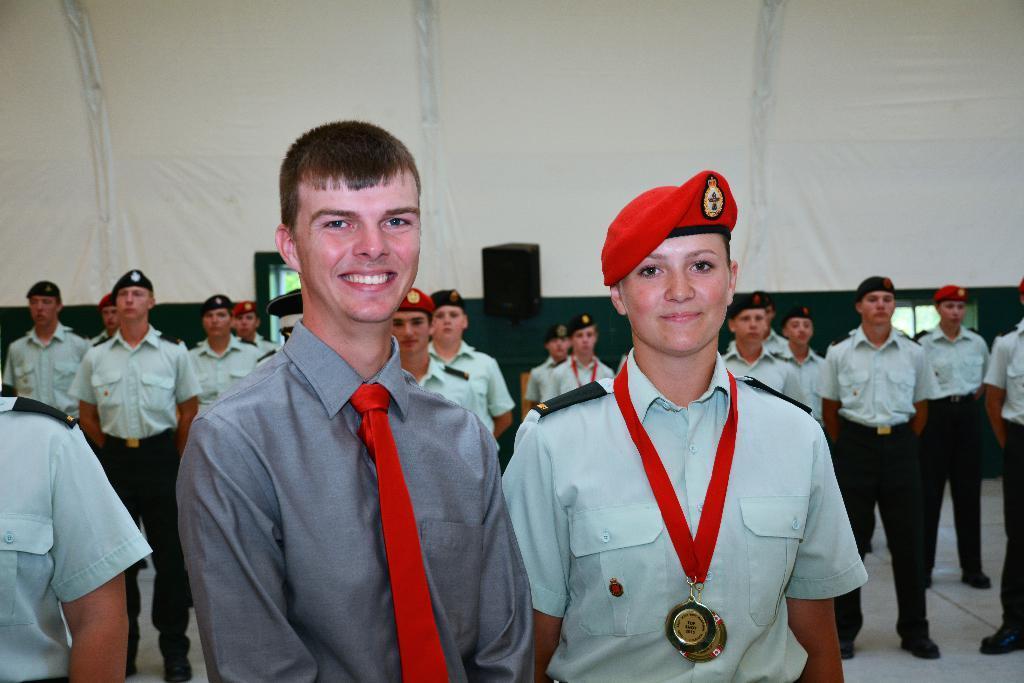How would you summarize this image in a sentence or two? In the picture I can see two persons standing and there is another person standing in the left corner and there are few other people standing behind them and there is a speaker and few other objects in the background. 